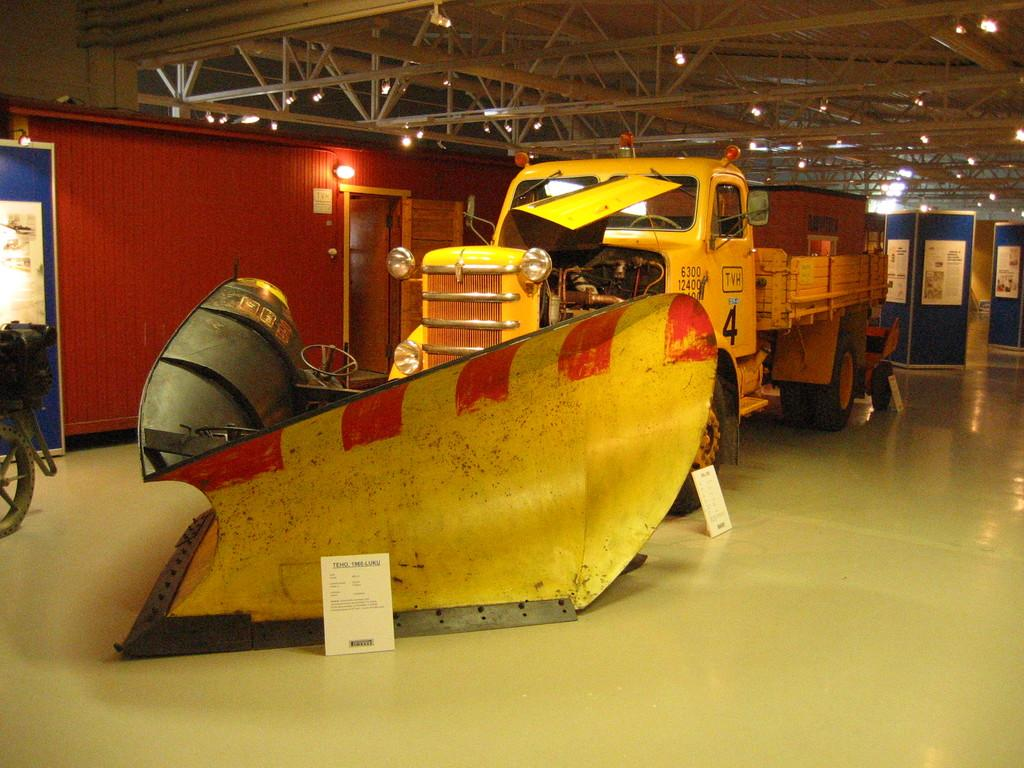What is the main subject in the center of the image? There are vehicles in the center of the image. Where are the vehicles located? The vehicles are on the floor. What can be seen in the background of the image? There are boards, lights, rods, and a door visible in the background. What is the structure of the space visible in the image? There is a door and a roof visible, indicating that it is likely an indoor space. What type of bun is being used as a toy by the vehicles in the image? There is no bun present in the image; the main subject is vehicles on the floor. How many trucks are visible in the image? The provided facts do not mention trucks specifically, but there are vehicles visible in the image. 